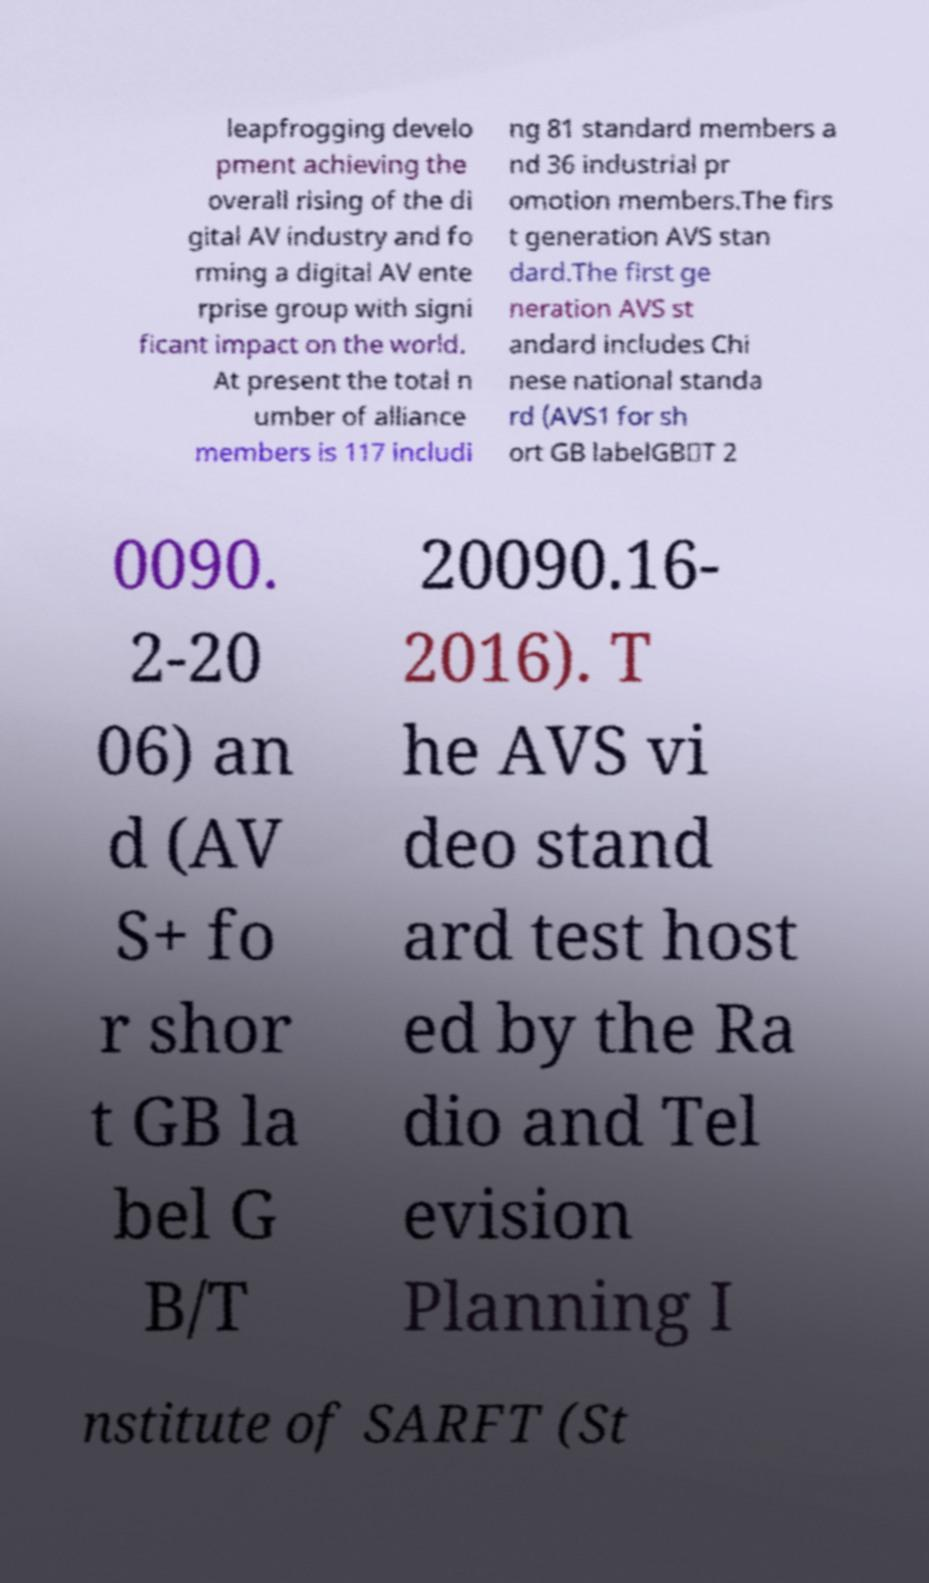For documentation purposes, I need the text within this image transcribed. Could you provide that? leapfrogging develo pment achieving the overall rising of the di gital AV industry and fo rming a digital AV ente rprise group with signi ficant impact on the world. At present the total n umber of alliance members is 117 includi ng 81 standard members a nd 36 industrial pr omotion members.The firs t generation AVS stan dard.The first ge neration AVS st andard includes Chi nese national standa rd (AVS1 for sh ort GB labelGB／T 2 0090. 2-20 06) an d (AV S+ fo r shor t GB la bel G B/T 20090.16- 2016). T he AVS vi deo stand ard test host ed by the Ra dio and Tel evision Planning I nstitute of SARFT (St 